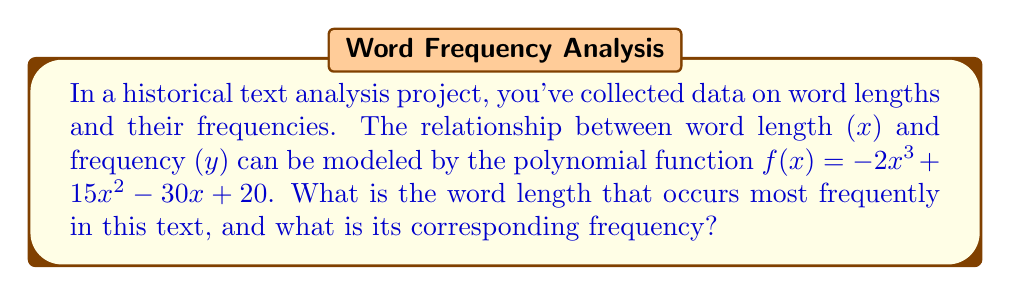Provide a solution to this math problem. To find the word length that occurs most frequently, we need to find the maximum point of the polynomial function. This can be done by following these steps:

1) First, we need to find the derivative of the function:
   $f'(x) = -6x^2 + 30x - 30$

2) To find the critical points, set $f'(x) = 0$:
   $-6x^2 + 30x - 30 = 0$

3) This is a quadratic equation. We can solve it using the quadratic formula:
   $x = \frac{-b \pm \sqrt{b^2 - 4ac}}{2a}$

   Where $a = -6$, $b = 30$, and $c = -30$

4) Plugging in these values:
   $x = \frac{-30 \pm \sqrt{30^2 - 4(-6)(-30)}}{2(-6)}$
   $= \frac{-30 \pm \sqrt{900 - 720}}{-12}$
   $= \frac{-30 \pm \sqrt{180}}{-12}$
   $= \frac{-30 \pm 6\sqrt{5}}{-12}$

5) This gives us two critical points:
   $x_1 = \frac{-30 + 6\sqrt{5}}{-12} = 2.5 + 0.5\sqrt{5}$
   $x_2 = \frac{-30 - 6\sqrt{5}}{-12} = 2.5 - 0.5\sqrt{5}$

6) To determine which point gives the maximum, we can use the second derivative test:
   $f''(x) = -12x + 30$

7) Evaluating $f''(x)$ at $x_1$:
   $f''(2.5 + 0.5\sqrt{5}) = -12(2.5 + 0.5\sqrt{5}) + 30 = -6\sqrt{5} < 0$

   Since $f''(x_1) < 0$, $x_1$ is a local maximum.

8) Therefore, the word length that occurs most frequently is $2.5 + 0.5\sqrt{5} \approx 3.618$ letters.

9) To find the corresponding frequency, we plug this value back into the original function:
   $f(2.5 + 0.5\sqrt{5}) = -2(2.5 + 0.5\sqrt{5})^3 + 15(2.5 + 0.5\sqrt{5})^2 - 30(2.5 + 0.5\sqrt{5}) + 20$

10) Simplifying this expression (which involves some complex algebra) gives us:
    $f(2.5 + 0.5\sqrt{5}) = 20 + 5\sqrt{5} \approx 31.180$

Therefore, the most frequent word length is approximately 3.618 letters, occurring with a frequency of approximately 31.180.
Answer: Word length: $2.5 + 0.5\sqrt{5} \approx 3.618$; Frequency: $20 + 5\sqrt{5} \approx 31.180$ 